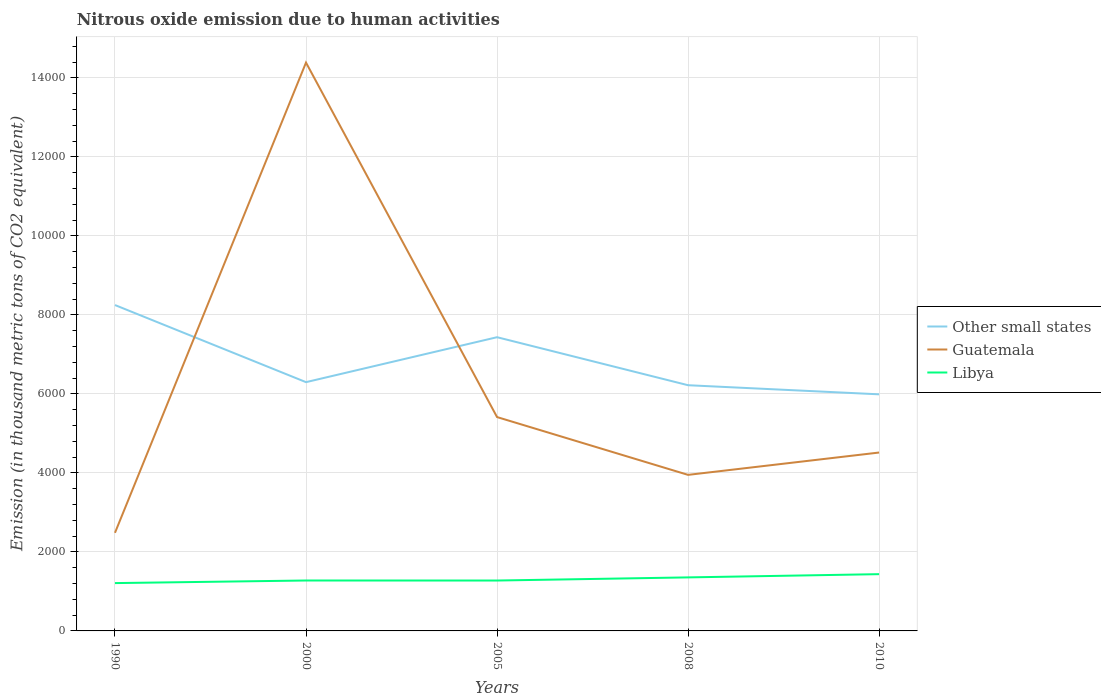How many different coloured lines are there?
Your answer should be very brief. 3. Is the number of lines equal to the number of legend labels?
Offer a very short reply. Yes. Across all years, what is the maximum amount of nitrous oxide emitted in Other small states?
Give a very brief answer. 5988.7. In which year was the amount of nitrous oxide emitted in Guatemala maximum?
Your response must be concise. 1990. What is the total amount of nitrous oxide emitted in Other small states in the graph?
Give a very brief answer. 308.3. What is the difference between the highest and the second highest amount of nitrous oxide emitted in Guatemala?
Ensure brevity in your answer.  1.19e+04. What is the difference between the highest and the lowest amount of nitrous oxide emitted in Other small states?
Keep it short and to the point. 2. How many lines are there?
Offer a very short reply. 3. How many years are there in the graph?
Your answer should be very brief. 5. What is the difference between two consecutive major ticks on the Y-axis?
Keep it short and to the point. 2000. Are the values on the major ticks of Y-axis written in scientific E-notation?
Offer a very short reply. No. Does the graph contain any zero values?
Offer a very short reply. No. Does the graph contain grids?
Keep it short and to the point. Yes. How many legend labels are there?
Provide a short and direct response. 3. What is the title of the graph?
Ensure brevity in your answer.  Nitrous oxide emission due to human activities. What is the label or title of the X-axis?
Provide a short and direct response. Years. What is the label or title of the Y-axis?
Your response must be concise. Emission (in thousand metric tons of CO2 equivalent). What is the Emission (in thousand metric tons of CO2 equivalent) in Other small states in 1990?
Keep it short and to the point. 8248.7. What is the Emission (in thousand metric tons of CO2 equivalent) of Guatemala in 1990?
Your answer should be compact. 2483.4. What is the Emission (in thousand metric tons of CO2 equivalent) of Libya in 1990?
Your answer should be compact. 1210.8. What is the Emission (in thousand metric tons of CO2 equivalent) of Other small states in 2000?
Your answer should be very brief. 6297. What is the Emission (in thousand metric tons of CO2 equivalent) in Guatemala in 2000?
Give a very brief answer. 1.44e+04. What is the Emission (in thousand metric tons of CO2 equivalent) of Libya in 2000?
Offer a very short reply. 1276.1. What is the Emission (in thousand metric tons of CO2 equivalent) of Other small states in 2005?
Your response must be concise. 7434.8. What is the Emission (in thousand metric tons of CO2 equivalent) of Guatemala in 2005?
Give a very brief answer. 5413.1. What is the Emission (in thousand metric tons of CO2 equivalent) of Libya in 2005?
Your response must be concise. 1275.5. What is the Emission (in thousand metric tons of CO2 equivalent) in Other small states in 2008?
Make the answer very short. 6219.3. What is the Emission (in thousand metric tons of CO2 equivalent) in Guatemala in 2008?
Provide a succinct answer. 3950.2. What is the Emission (in thousand metric tons of CO2 equivalent) of Libya in 2008?
Your answer should be compact. 1355. What is the Emission (in thousand metric tons of CO2 equivalent) in Other small states in 2010?
Give a very brief answer. 5988.7. What is the Emission (in thousand metric tons of CO2 equivalent) of Guatemala in 2010?
Provide a short and direct response. 4515.5. What is the Emission (in thousand metric tons of CO2 equivalent) in Libya in 2010?
Provide a succinct answer. 1436.9. Across all years, what is the maximum Emission (in thousand metric tons of CO2 equivalent) of Other small states?
Ensure brevity in your answer.  8248.7. Across all years, what is the maximum Emission (in thousand metric tons of CO2 equivalent) of Guatemala?
Offer a terse response. 1.44e+04. Across all years, what is the maximum Emission (in thousand metric tons of CO2 equivalent) in Libya?
Your response must be concise. 1436.9. Across all years, what is the minimum Emission (in thousand metric tons of CO2 equivalent) in Other small states?
Make the answer very short. 5988.7. Across all years, what is the minimum Emission (in thousand metric tons of CO2 equivalent) of Guatemala?
Give a very brief answer. 2483.4. Across all years, what is the minimum Emission (in thousand metric tons of CO2 equivalent) in Libya?
Your response must be concise. 1210.8. What is the total Emission (in thousand metric tons of CO2 equivalent) in Other small states in the graph?
Ensure brevity in your answer.  3.42e+04. What is the total Emission (in thousand metric tons of CO2 equivalent) of Guatemala in the graph?
Your response must be concise. 3.07e+04. What is the total Emission (in thousand metric tons of CO2 equivalent) in Libya in the graph?
Give a very brief answer. 6554.3. What is the difference between the Emission (in thousand metric tons of CO2 equivalent) in Other small states in 1990 and that in 2000?
Your answer should be very brief. 1951.7. What is the difference between the Emission (in thousand metric tons of CO2 equivalent) of Guatemala in 1990 and that in 2000?
Provide a short and direct response. -1.19e+04. What is the difference between the Emission (in thousand metric tons of CO2 equivalent) in Libya in 1990 and that in 2000?
Provide a succinct answer. -65.3. What is the difference between the Emission (in thousand metric tons of CO2 equivalent) in Other small states in 1990 and that in 2005?
Provide a short and direct response. 813.9. What is the difference between the Emission (in thousand metric tons of CO2 equivalent) of Guatemala in 1990 and that in 2005?
Ensure brevity in your answer.  -2929.7. What is the difference between the Emission (in thousand metric tons of CO2 equivalent) in Libya in 1990 and that in 2005?
Offer a terse response. -64.7. What is the difference between the Emission (in thousand metric tons of CO2 equivalent) in Other small states in 1990 and that in 2008?
Provide a succinct answer. 2029.4. What is the difference between the Emission (in thousand metric tons of CO2 equivalent) of Guatemala in 1990 and that in 2008?
Keep it short and to the point. -1466.8. What is the difference between the Emission (in thousand metric tons of CO2 equivalent) of Libya in 1990 and that in 2008?
Offer a very short reply. -144.2. What is the difference between the Emission (in thousand metric tons of CO2 equivalent) in Other small states in 1990 and that in 2010?
Offer a terse response. 2260. What is the difference between the Emission (in thousand metric tons of CO2 equivalent) in Guatemala in 1990 and that in 2010?
Offer a very short reply. -2032.1. What is the difference between the Emission (in thousand metric tons of CO2 equivalent) of Libya in 1990 and that in 2010?
Provide a succinct answer. -226.1. What is the difference between the Emission (in thousand metric tons of CO2 equivalent) in Other small states in 2000 and that in 2005?
Your answer should be compact. -1137.8. What is the difference between the Emission (in thousand metric tons of CO2 equivalent) in Guatemala in 2000 and that in 2005?
Give a very brief answer. 8972.6. What is the difference between the Emission (in thousand metric tons of CO2 equivalent) in Other small states in 2000 and that in 2008?
Keep it short and to the point. 77.7. What is the difference between the Emission (in thousand metric tons of CO2 equivalent) of Guatemala in 2000 and that in 2008?
Offer a very short reply. 1.04e+04. What is the difference between the Emission (in thousand metric tons of CO2 equivalent) of Libya in 2000 and that in 2008?
Keep it short and to the point. -78.9. What is the difference between the Emission (in thousand metric tons of CO2 equivalent) of Other small states in 2000 and that in 2010?
Your response must be concise. 308.3. What is the difference between the Emission (in thousand metric tons of CO2 equivalent) of Guatemala in 2000 and that in 2010?
Keep it short and to the point. 9870.2. What is the difference between the Emission (in thousand metric tons of CO2 equivalent) in Libya in 2000 and that in 2010?
Your answer should be very brief. -160.8. What is the difference between the Emission (in thousand metric tons of CO2 equivalent) of Other small states in 2005 and that in 2008?
Your response must be concise. 1215.5. What is the difference between the Emission (in thousand metric tons of CO2 equivalent) in Guatemala in 2005 and that in 2008?
Offer a very short reply. 1462.9. What is the difference between the Emission (in thousand metric tons of CO2 equivalent) of Libya in 2005 and that in 2008?
Keep it short and to the point. -79.5. What is the difference between the Emission (in thousand metric tons of CO2 equivalent) in Other small states in 2005 and that in 2010?
Your answer should be compact. 1446.1. What is the difference between the Emission (in thousand metric tons of CO2 equivalent) of Guatemala in 2005 and that in 2010?
Make the answer very short. 897.6. What is the difference between the Emission (in thousand metric tons of CO2 equivalent) of Libya in 2005 and that in 2010?
Your answer should be compact. -161.4. What is the difference between the Emission (in thousand metric tons of CO2 equivalent) in Other small states in 2008 and that in 2010?
Your answer should be compact. 230.6. What is the difference between the Emission (in thousand metric tons of CO2 equivalent) of Guatemala in 2008 and that in 2010?
Give a very brief answer. -565.3. What is the difference between the Emission (in thousand metric tons of CO2 equivalent) in Libya in 2008 and that in 2010?
Offer a very short reply. -81.9. What is the difference between the Emission (in thousand metric tons of CO2 equivalent) of Other small states in 1990 and the Emission (in thousand metric tons of CO2 equivalent) of Guatemala in 2000?
Provide a succinct answer. -6137. What is the difference between the Emission (in thousand metric tons of CO2 equivalent) of Other small states in 1990 and the Emission (in thousand metric tons of CO2 equivalent) of Libya in 2000?
Your answer should be compact. 6972.6. What is the difference between the Emission (in thousand metric tons of CO2 equivalent) in Guatemala in 1990 and the Emission (in thousand metric tons of CO2 equivalent) in Libya in 2000?
Provide a succinct answer. 1207.3. What is the difference between the Emission (in thousand metric tons of CO2 equivalent) in Other small states in 1990 and the Emission (in thousand metric tons of CO2 equivalent) in Guatemala in 2005?
Ensure brevity in your answer.  2835.6. What is the difference between the Emission (in thousand metric tons of CO2 equivalent) in Other small states in 1990 and the Emission (in thousand metric tons of CO2 equivalent) in Libya in 2005?
Your answer should be very brief. 6973.2. What is the difference between the Emission (in thousand metric tons of CO2 equivalent) of Guatemala in 1990 and the Emission (in thousand metric tons of CO2 equivalent) of Libya in 2005?
Make the answer very short. 1207.9. What is the difference between the Emission (in thousand metric tons of CO2 equivalent) of Other small states in 1990 and the Emission (in thousand metric tons of CO2 equivalent) of Guatemala in 2008?
Give a very brief answer. 4298.5. What is the difference between the Emission (in thousand metric tons of CO2 equivalent) of Other small states in 1990 and the Emission (in thousand metric tons of CO2 equivalent) of Libya in 2008?
Give a very brief answer. 6893.7. What is the difference between the Emission (in thousand metric tons of CO2 equivalent) in Guatemala in 1990 and the Emission (in thousand metric tons of CO2 equivalent) in Libya in 2008?
Give a very brief answer. 1128.4. What is the difference between the Emission (in thousand metric tons of CO2 equivalent) of Other small states in 1990 and the Emission (in thousand metric tons of CO2 equivalent) of Guatemala in 2010?
Make the answer very short. 3733.2. What is the difference between the Emission (in thousand metric tons of CO2 equivalent) in Other small states in 1990 and the Emission (in thousand metric tons of CO2 equivalent) in Libya in 2010?
Offer a terse response. 6811.8. What is the difference between the Emission (in thousand metric tons of CO2 equivalent) of Guatemala in 1990 and the Emission (in thousand metric tons of CO2 equivalent) of Libya in 2010?
Make the answer very short. 1046.5. What is the difference between the Emission (in thousand metric tons of CO2 equivalent) of Other small states in 2000 and the Emission (in thousand metric tons of CO2 equivalent) of Guatemala in 2005?
Keep it short and to the point. 883.9. What is the difference between the Emission (in thousand metric tons of CO2 equivalent) in Other small states in 2000 and the Emission (in thousand metric tons of CO2 equivalent) in Libya in 2005?
Give a very brief answer. 5021.5. What is the difference between the Emission (in thousand metric tons of CO2 equivalent) in Guatemala in 2000 and the Emission (in thousand metric tons of CO2 equivalent) in Libya in 2005?
Ensure brevity in your answer.  1.31e+04. What is the difference between the Emission (in thousand metric tons of CO2 equivalent) in Other small states in 2000 and the Emission (in thousand metric tons of CO2 equivalent) in Guatemala in 2008?
Provide a short and direct response. 2346.8. What is the difference between the Emission (in thousand metric tons of CO2 equivalent) in Other small states in 2000 and the Emission (in thousand metric tons of CO2 equivalent) in Libya in 2008?
Make the answer very short. 4942. What is the difference between the Emission (in thousand metric tons of CO2 equivalent) of Guatemala in 2000 and the Emission (in thousand metric tons of CO2 equivalent) of Libya in 2008?
Provide a succinct answer. 1.30e+04. What is the difference between the Emission (in thousand metric tons of CO2 equivalent) of Other small states in 2000 and the Emission (in thousand metric tons of CO2 equivalent) of Guatemala in 2010?
Your answer should be compact. 1781.5. What is the difference between the Emission (in thousand metric tons of CO2 equivalent) in Other small states in 2000 and the Emission (in thousand metric tons of CO2 equivalent) in Libya in 2010?
Provide a short and direct response. 4860.1. What is the difference between the Emission (in thousand metric tons of CO2 equivalent) of Guatemala in 2000 and the Emission (in thousand metric tons of CO2 equivalent) of Libya in 2010?
Provide a succinct answer. 1.29e+04. What is the difference between the Emission (in thousand metric tons of CO2 equivalent) of Other small states in 2005 and the Emission (in thousand metric tons of CO2 equivalent) of Guatemala in 2008?
Offer a terse response. 3484.6. What is the difference between the Emission (in thousand metric tons of CO2 equivalent) of Other small states in 2005 and the Emission (in thousand metric tons of CO2 equivalent) of Libya in 2008?
Provide a short and direct response. 6079.8. What is the difference between the Emission (in thousand metric tons of CO2 equivalent) of Guatemala in 2005 and the Emission (in thousand metric tons of CO2 equivalent) of Libya in 2008?
Offer a terse response. 4058.1. What is the difference between the Emission (in thousand metric tons of CO2 equivalent) of Other small states in 2005 and the Emission (in thousand metric tons of CO2 equivalent) of Guatemala in 2010?
Your answer should be very brief. 2919.3. What is the difference between the Emission (in thousand metric tons of CO2 equivalent) in Other small states in 2005 and the Emission (in thousand metric tons of CO2 equivalent) in Libya in 2010?
Offer a very short reply. 5997.9. What is the difference between the Emission (in thousand metric tons of CO2 equivalent) in Guatemala in 2005 and the Emission (in thousand metric tons of CO2 equivalent) in Libya in 2010?
Your answer should be compact. 3976.2. What is the difference between the Emission (in thousand metric tons of CO2 equivalent) of Other small states in 2008 and the Emission (in thousand metric tons of CO2 equivalent) of Guatemala in 2010?
Provide a short and direct response. 1703.8. What is the difference between the Emission (in thousand metric tons of CO2 equivalent) of Other small states in 2008 and the Emission (in thousand metric tons of CO2 equivalent) of Libya in 2010?
Offer a terse response. 4782.4. What is the difference between the Emission (in thousand metric tons of CO2 equivalent) in Guatemala in 2008 and the Emission (in thousand metric tons of CO2 equivalent) in Libya in 2010?
Ensure brevity in your answer.  2513.3. What is the average Emission (in thousand metric tons of CO2 equivalent) in Other small states per year?
Your answer should be compact. 6837.7. What is the average Emission (in thousand metric tons of CO2 equivalent) in Guatemala per year?
Make the answer very short. 6149.58. What is the average Emission (in thousand metric tons of CO2 equivalent) in Libya per year?
Offer a very short reply. 1310.86. In the year 1990, what is the difference between the Emission (in thousand metric tons of CO2 equivalent) of Other small states and Emission (in thousand metric tons of CO2 equivalent) of Guatemala?
Your response must be concise. 5765.3. In the year 1990, what is the difference between the Emission (in thousand metric tons of CO2 equivalent) in Other small states and Emission (in thousand metric tons of CO2 equivalent) in Libya?
Provide a succinct answer. 7037.9. In the year 1990, what is the difference between the Emission (in thousand metric tons of CO2 equivalent) of Guatemala and Emission (in thousand metric tons of CO2 equivalent) of Libya?
Provide a short and direct response. 1272.6. In the year 2000, what is the difference between the Emission (in thousand metric tons of CO2 equivalent) in Other small states and Emission (in thousand metric tons of CO2 equivalent) in Guatemala?
Provide a succinct answer. -8088.7. In the year 2000, what is the difference between the Emission (in thousand metric tons of CO2 equivalent) of Other small states and Emission (in thousand metric tons of CO2 equivalent) of Libya?
Provide a succinct answer. 5020.9. In the year 2000, what is the difference between the Emission (in thousand metric tons of CO2 equivalent) of Guatemala and Emission (in thousand metric tons of CO2 equivalent) of Libya?
Make the answer very short. 1.31e+04. In the year 2005, what is the difference between the Emission (in thousand metric tons of CO2 equivalent) in Other small states and Emission (in thousand metric tons of CO2 equivalent) in Guatemala?
Your answer should be very brief. 2021.7. In the year 2005, what is the difference between the Emission (in thousand metric tons of CO2 equivalent) of Other small states and Emission (in thousand metric tons of CO2 equivalent) of Libya?
Ensure brevity in your answer.  6159.3. In the year 2005, what is the difference between the Emission (in thousand metric tons of CO2 equivalent) in Guatemala and Emission (in thousand metric tons of CO2 equivalent) in Libya?
Keep it short and to the point. 4137.6. In the year 2008, what is the difference between the Emission (in thousand metric tons of CO2 equivalent) in Other small states and Emission (in thousand metric tons of CO2 equivalent) in Guatemala?
Offer a terse response. 2269.1. In the year 2008, what is the difference between the Emission (in thousand metric tons of CO2 equivalent) of Other small states and Emission (in thousand metric tons of CO2 equivalent) of Libya?
Give a very brief answer. 4864.3. In the year 2008, what is the difference between the Emission (in thousand metric tons of CO2 equivalent) of Guatemala and Emission (in thousand metric tons of CO2 equivalent) of Libya?
Give a very brief answer. 2595.2. In the year 2010, what is the difference between the Emission (in thousand metric tons of CO2 equivalent) of Other small states and Emission (in thousand metric tons of CO2 equivalent) of Guatemala?
Your response must be concise. 1473.2. In the year 2010, what is the difference between the Emission (in thousand metric tons of CO2 equivalent) in Other small states and Emission (in thousand metric tons of CO2 equivalent) in Libya?
Give a very brief answer. 4551.8. In the year 2010, what is the difference between the Emission (in thousand metric tons of CO2 equivalent) of Guatemala and Emission (in thousand metric tons of CO2 equivalent) of Libya?
Keep it short and to the point. 3078.6. What is the ratio of the Emission (in thousand metric tons of CO2 equivalent) in Other small states in 1990 to that in 2000?
Provide a short and direct response. 1.31. What is the ratio of the Emission (in thousand metric tons of CO2 equivalent) in Guatemala in 1990 to that in 2000?
Keep it short and to the point. 0.17. What is the ratio of the Emission (in thousand metric tons of CO2 equivalent) of Libya in 1990 to that in 2000?
Keep it short and to the point. 0.95. What is the ratio of the Emission (in thousand metric tons of CO2 equivalent) in Other small states in 1990 to that in 2005?
Your response must be concise. 1.11. What is the ratio of the Emission (in thousand metric tons of CO2 equivalent) of Guatemala in 1990 to that in 2005?
Keep it short and to the point. 0.46. What is the ratio of the Emission (in thousand metric tons of CO2 equivalent) of Libya in 1990 to that in 2005?
Your response must be concise. 0.95. What is the ratio of the Emission (in thousand metric tons of CO2 equivalent) of Other small states in 1990 to that in 2008?
Offer a terse response. 1.33. What is the ratio of the Emission (in thousand metric tons of CO2 equivalent) in Guatemala in 1990 to that in 2008?
Your response must be concise. 0.63. What is the ratio of the Emission (in thousand metric tons of CO2 equivalent) of Libya in 1990 to that in 2008?
Provide a succinct answer. 0.89. What is the ratio of the Emission (in thousand metric tons of CO2 equivalent) of Other small states in 1990 to that in 2010?
Provide a succinct answer. 1.38. What is the ratio of the Emission (in thousand metric tons of CO2 equivalent) in Guatemala in 1990 to that in 2010?
Provide a succinct answer. 0.55. What is the ratio of the Emission (in thousand metric tons of CO2 equivalent) in Libya in 1990 to that in 2010?
Ensure brevity in your answer.  0.84. What is the ratio of the Emission (in thousand metric tons of CO2 equivalent) of Other small states in 2000 to that in 2005?
Your answer should be compact. 0.85. What is the ratio of the Emission (in thousand metric tons of CO2 equivalent) of Guatemala in 2000 to that in 2005?
Make the answer very short. 2.66. What is the ratio of the Emission (in thousand metric tons of CO2 equivalent) of Other small states in 2000 to that in 2008?
Ensure brevity in your answer.  1.01. What is the ratio of the Emission (in thousand metric tons of CO2 equivalent) of Guatemala in 2000 to that in 2008?
Offer a terse response. 3.64. What is the ratio of the Emission (in thousand metric tons of CO2 equivalent) in Libya in 2000 to that in 2008?
Provide a short and direct response. 0.94. What is the ratio of the Emission (in thousand metric tons of CO2 equivalent) in Other small states in 2000 to that in 2010?
Give a very brief answer. 1.05. What is the ratio of the Emission (in thousand metric tons of CO2 equivalent) in Guatemala in 2000 to that in 2010?
Keep it short and to the point. 3.19. What is the ratio of the Emission (in thousand metric tons of CO2 equivalent) in Libya in 2000 to that in 2010?
Offer a terse response. 0.89. What is the ratio of the Emission (in thousand metric tons of CO2 equivalent) in Other small states in 2005 to that in 2008?
Your response must be concise. 1.2. What is the ratio of the Emission (in thousand metric tons of CO2 equivalent) of Guatemala in 2005 to that in 2008?
Provide a short and direct response. 1.37. What is the ratio of the Emission (in thousand metric tons of CO2 equivalent) of Libya in 2005 to that in 2008?
Your response must be concise. 0.94. What is the ratio of the Emission (in thousand metric tons of CO2 equivalent) in Other small states in 2005 to that in 2010?
Offer a very short reply. 1.24. What is the ratio of the Emission (in thousand metric tons of CO2 equivalent) in Guatemala in 2005 to that in 2010?
Offer a very short reply. 1.2. What is the ratio of the Emission (in thousand metric tons of CO2 equivalent) in Libya in 2005 to that in 2010?
Ensure brevity in your answer.  0.89. What is the ratio of the Emission (in thousand metric tons of CO2 equivalent) in Other small states in 2008 to that in 2010?
Ensure brevity in your answer.  1.04. What is the ratio of the Emission (in thousand metric tons of CO2 equivalent) of Guatemala in 2008 to that in 2010?
Make the answer very short. 0.87. What is the ratio of the Emission (in thousand metric tons of CO2 equivalent) in Libya in 2008 to that in 2010?
Keep it short and to the point. 0.94. What is the difference between the highest and the second highest Emission (in thousand metric tons of CO2 equivalent) of Other small states?
Your response must be concise. 813.9. What is the difference between the highest and the second highest Emission (in thousand metric tons of CO2 equivalent) of Guatemala?
Make the answer very short. 8972.6. What is the difference between the highest and the second highest Emission (in thousand metric tons of CO2 equivalent) of Libya?
Offer a terse response. 81.9. What is the difference between the highest and the lowest Emission (in thousand metric tons of CO2 equivalent) of Other small states?
Make the answer very short. 2260. What is the difference between the highest and the lowest Emission (in thousand metric tons of CO2 equivalent) in Guatemala?
Make the answer very short. 1.19e+04. What is the difference between the highest and the lowest Emission (in thousand metric tons of CO2 equivalent) of Libya?
Ensure brevity in your answer.  226.1. 